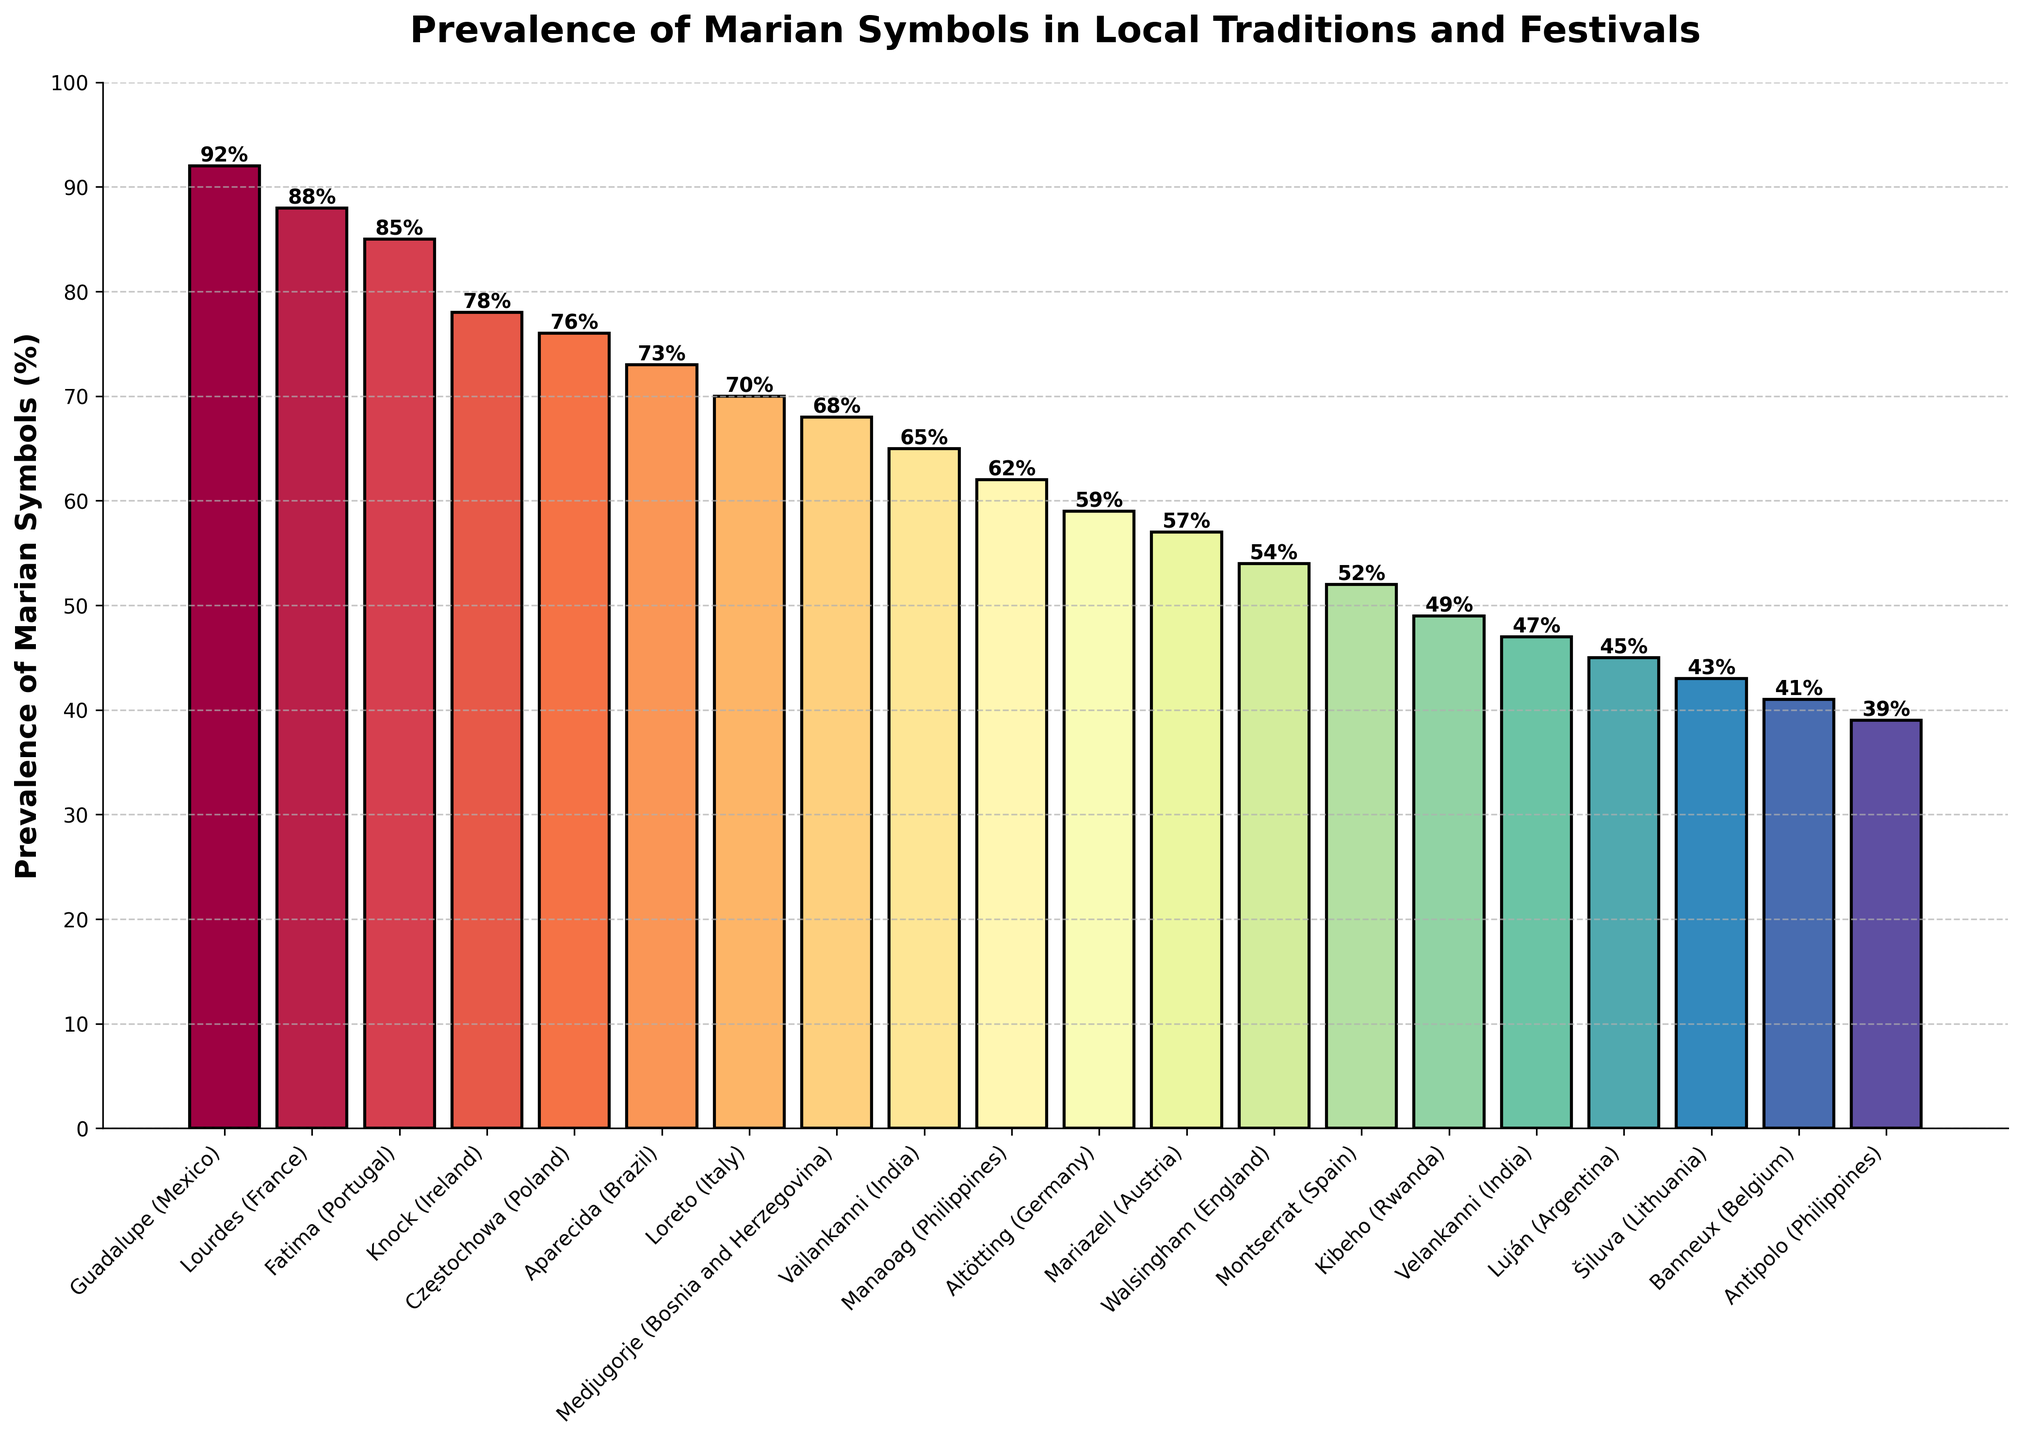What region shows the highest prevalence of Marian symbols? The bar for Guadalupe (Mexico) reaches the highest point, indicating 92% prevalence.
Answer: Guadalupe (Mexico), 92% What is the difference in the prevalence of Marian symbols between Lourdes (France) and Šiluva (Lithuania)? Lourdes has 88% prevalence, while Šiluva has 43%. The difference is 88% - 43% = 45%.
Answer: 45% Which region between Fatima (Portugal) and Aparecida (Brazil) has a higher percentage, and by how much? Fatima has 85% prevalence, and Aparecida has 73%. The difference is 85% - 73% = 12%.
Answer: Fatima, 12% What is the average prevalence of Marian symbols for the top three regions? Guadalupe (2), Lourdes (88), and Fatima (85) have the highest values. The average is (92 + 88 + 85) / 3 = 88.33%.
Answer: 88.33% Are there more regions with prevalence above or below 70%? Count the regions above 70%: Guadalupe, Lourdes, Fatima, Knock, Częstochowa, Aparecida, Loreto (7). Count the regions below 70%: Medjugorje, Vailankanni, Manaoag, Altötting, Mariazell, Walsingham, Montserrat, Kibeho, Velankanni, Luján, Šiluva, Banneux, Antipolo (13). There are more regions below 70%.
Answer: Below 70% What is the combined prevalence of Marian symbols for the regions in the Philippines? Manaoag has 62%, and Antipolo has 39%. Combined, it is 62% + 39% = 101%.
Answer: 101% Which region in Italy shows the prevalence of Marian symbols, and is it higher or lower than in Medjugorje (Bosnia and Herzegovina)? Loreto (Italy) has 70%. Medjugorje (Bosnia and Herzegovina) has 68%. 70% is higher than 68%.
Answer: Higher, 70% List the regions with a prevalence of Marian symbols less than 50%. The regions with less than 50% prevalence according to the bars are: Kibeho, Velankanni (India), Luján, Šiluva, Banneux, Antipolo.
Answer: Kibeho, Velankanni (India), Luján, Šiluva, Banneux, Antipolo Which region has the closest prevalence to 60% and what is the exact percentage? Altötting (Germany) has a prevalence of 59%, which is closest to 60%.
Answer: Altötting, 59% What is the prevalence range of the Marian symbols (the difference between the highest and lowest prevalence)? The highest value is Guadalupe (92%), and the lowest value is Antipolo (39%). The range is 92% - 39% = 53%.
Answer: 53% 